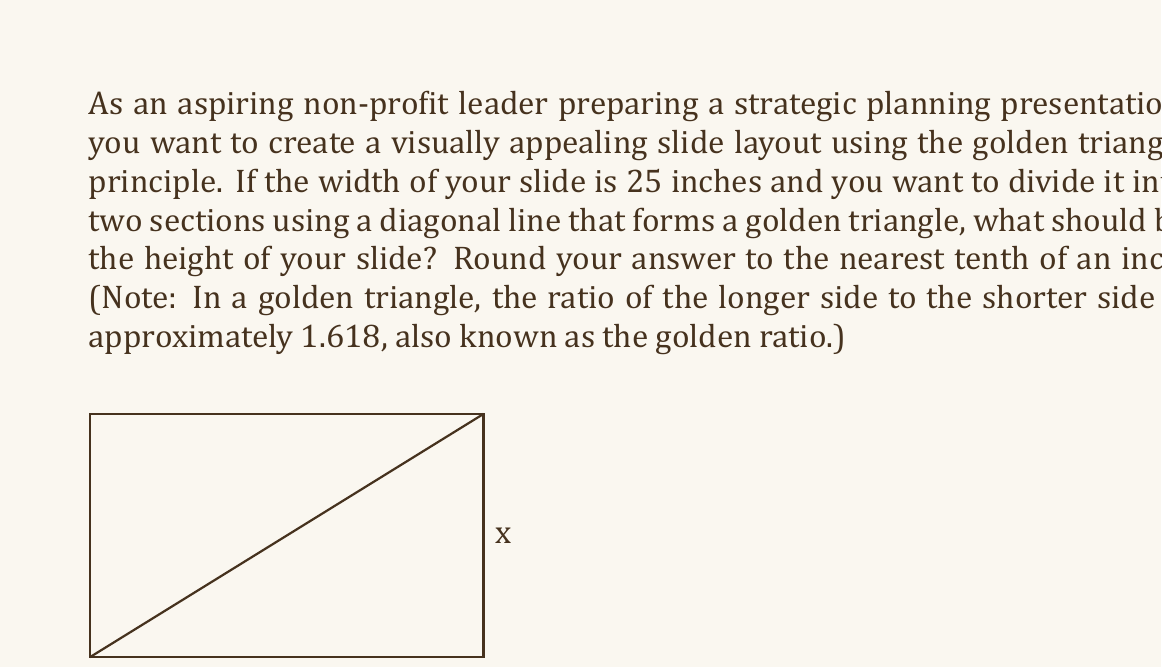Can you answer this question? Let's approach this step-by-step:

1) In a golden triangle, the ratio of the longer side to the shorter side is approximately 1.618 (the golden ratio). Let's call this ratio $\phi$.

2) If we denote the height of the slide as $x$, we can set up the following proportion:

   $$\frac{25}{x} = \phi \approx 1.618$$

3) To solve for $x$, we can cross-multiply:

   $$25 = 1.618x$$

4) Now, let's divide both sides by 1.618:

   $$\frac{25}{1.618} = x$$

5) Using a calculator or computer, we can compute this value:

   $$x \approx 15.4509...$$

6) Rounding to the nearest tenth of an inch as requested:

   $$x \approx 15.5\text{ inches}$$

This height will create a slide with proportions that follow the golden ratio, which is often considered aesthetically pleasing and can help create an effective presentation layout.
Answer: 15.5 inches 